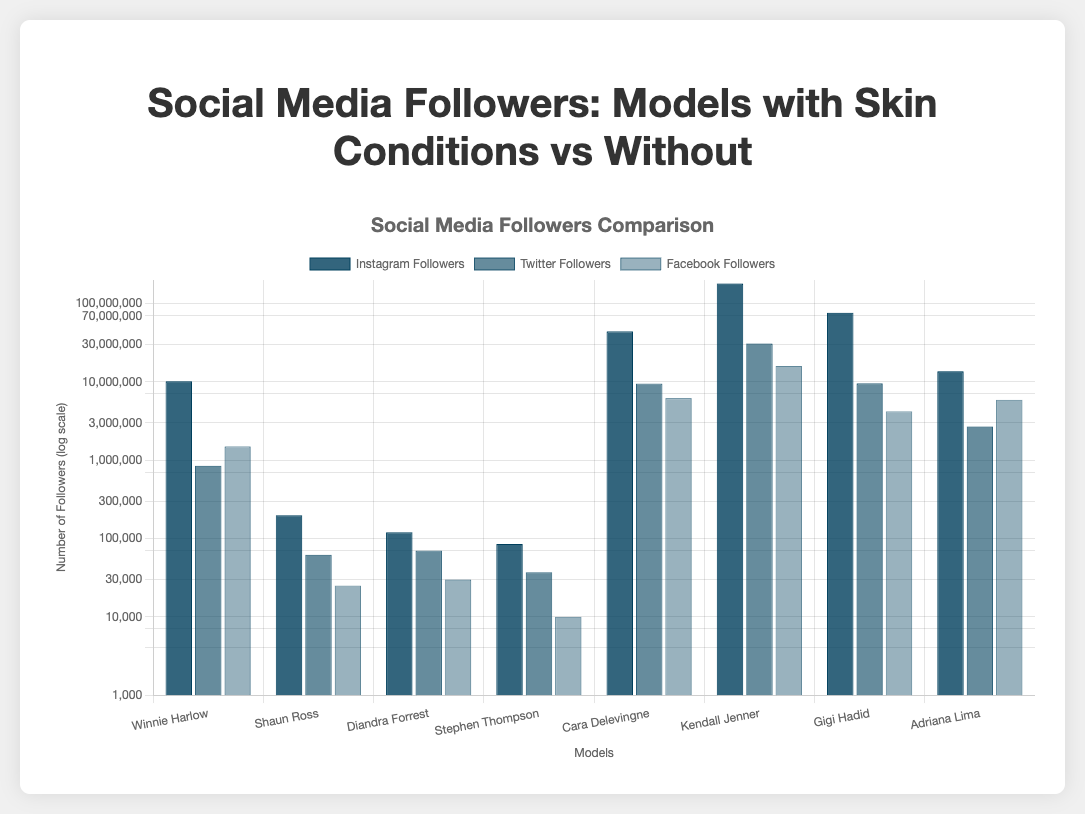What is the total number of Instagram followers for models with skin conditions? Add the Instagram followers from Winnie Harlow, Shaun Ross, Diandra Forrest, and Stephen Thompson, which is 10,200,000 + 198,000 + 120,000 + 85,000 = 10,603,000.
Answer: 10,603,000 Which model has the highest number of Twitter followers? Kendall Jenner has the highest number of Twitter followers, seen by comparing the heights of the Twitter followers' bars.
Answer: Kendall Jenner For models without skin conditions, what is the average number of Facebook followers? Add the Facebook followers of Cara Delevingne, Kendall Jenner, Gigi Hadid, and Adriana Lima, which is 6,200,000 + 16,000,000 + 4,200,000 + 5,900,000 = 32,300,000. Divide by 4 to get the average: 32,300,000 / 4 = 8,075,000.
Answer: 8,075,000 How do the Instagram followers of models with skin conditions compare to those without? Compare the total Instagram followers for models with skin conditions (10,603,000) to the total for those without (317,200,000). Models without skin conditions have significantly more Instagram followers.
Answer: Models without have more Which social media platform has the smallest follower count for Winnie Harlow? Compare the heights of the bars representing Winnie Harlow's followers: Instagram (10,200,000), Twitter (850,000), and Facebook (1,500,000). Twitter has the smallest count.
Answer: Twitter What is the ratio of Instagram followers between Kendall Jenner and Winnie Harlow? Divide Kendall Jenner's Instagram followers (181,000,000) by Winnie Harlow's (10,200,000): 181,000,000 / 10,200,000 = 17.75.
Answer: 17.75 Who has more Facebook followers, Gigi Hadid or Adriana Lima? Compare the heights of the Facebook follower bars for Gigi Hadid (4,200,000) and Adriana Lima (5,900,000). Adriana Lima has more.
Answer: Adriana Lima How many total followers does Diandra Forrest have across all platforms? Add the Instagram, Twitter, and Facebook followers for Diandra Forrest: 120,000 + 70,000 + 30,000 = 220,000.
Answer: 220,000 Which model with a skin condition has the most total followers? Compare the total follower counts for Winnie Harlow, Shaun Ross, Diandra Forrest, and Stephen Thompson. Winnie Harlow has the most with 12,550,000 (10,200,000 Instagram + 850,000 Twitter + 1,500,000 Facebook).
Answer: Winnie Harlow 